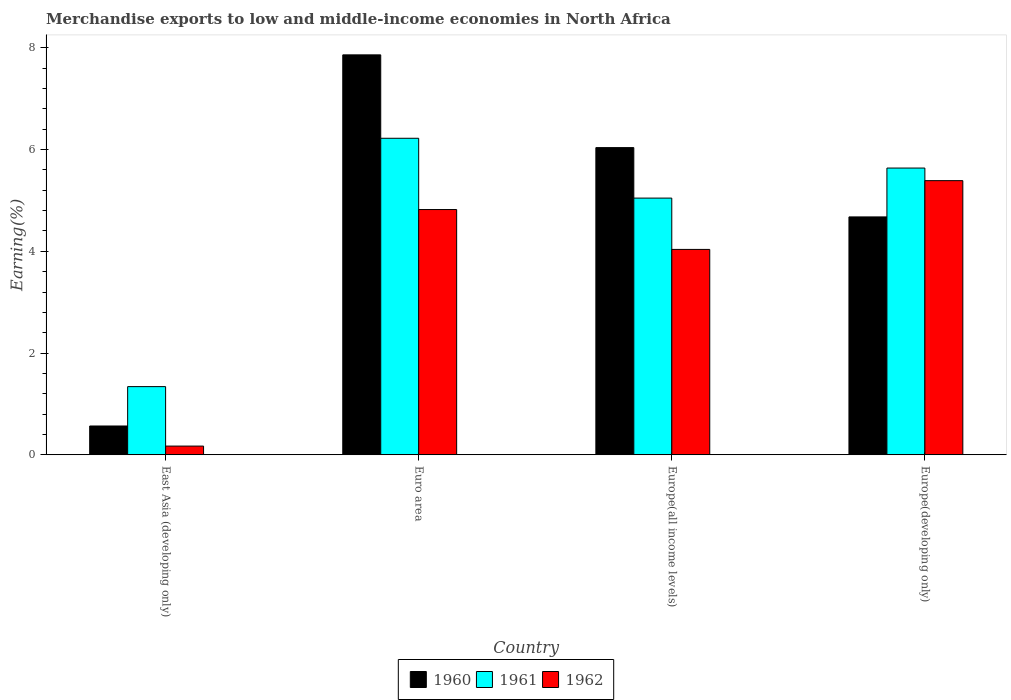How many different coloured bars are there?
Provide a succinct answer. 3. How many groups of bars are there?
Give a very brief answer. 4. How many bars are there on the 2nd tick from the right?
Give a very brief answer. 3. What is the label of the 2nd group of bars from the left?
Your answer should be very brief. Euro area. What is the percentage of amount earned from merchandise exports in 1962 in Europe(developing only)?
Your answer should be compact. 5.39. Across all countries, what is the maximum percentage of amount earned from merchandise exports in 1960?
Your answer should be compact. 7.86. Across all countries, what is the minimum percentage of amount earned from merchandise exports in 1960?
Your answer should be very brief. 0.57. In which country was the percentage of amount earned from merchandise exports in 1962 maximum?
Give a very brief answer. Europe(developing only). In which country was the percentage of amount earned from merchandise exports in 1961 minimum?
Offer a very short reply. East Asia (developing only). What is the total percentage of amount earned from merchandise exports in 1962 in the graph?
Your answer should be compact. 14.42. What is the difference between the percentage of amount earned from merchandise exports in 1961 in Euro area and that in Europe(developing only)?
Your answer should be very brief. 0.59. What is the difference between the percentage of amount earned from merchandise exports in 1960 in Euro area and the percentage of amount earned from merchandise exports in 1962 in Europe(all income levels)?
Provide a succinct answer. 3.82. What is the average percentage of amount earned from merchandise exports in 1961 per country?
Provide a short and direct response. 4.56. What is the difference between the percentage of amount earned from merchandise exports of/in 1962 and percentage of amount earned from merchandise exports of/in 1960 in Europe(developing only)?
Ensure brevity in your answer.  0.71. What is the ratio of the percentage of amount earned from merchandise exports in 1961 in Euro area to that in Europe(all income levels)?
Provide a succinct answer. 1.23. What is the difference between the highest and the second highest percentage of amount earned from merchandise exports in 1960?
Offer a very short reply. -1.36. What is the difference between the highest and the lowest percentage of amount earned from merchandise exports in 1962?
Your answer should be very brief. 5.22. Is the sum of the percentage of amount earned from merchandise exports in 1960 in Europe(all income levels) and Europe(developing only) greater than the maximum percentage of amount earned from merchandise exports in 1961 across all countries?
Make the answer very short. Yes. Are all the bars in the graph horizontal?
Provide a succinct answer. No. How many countries are there in the graph?
Your response must be concise. 4. What is the difference between two consecutive major ticks on the Y-axis?
Your answer should be very brief. 2. Are the values on the major ticks of Y-axis written in scientific E-notation?
Provide a short and direct response. No. How many legend labels are there?
Make the answer very short. 3. How are the legend labels stacked?
Ensure brevity in your answer.  Horizontal. What is the title of the graph?
Give a very brief answer. Merchandise exports to low and middle-income economies in North Africa. Does "1998" appear as one of the legend labels in the graph?
Keep it short and to the point. No. What is the label or title of the Y-axis?
Your response must be concise. Earning(%). What is the Earning(%) of 1960 in East Asia (developing only)?
Your response must be concise. 0.57. What is the Earning(%) of 1961 in East Asia (developing only)?
Ensure brevity in your answer.  1.34. What is the Earning(%) in 1962 in East Asia (developing only)?
Your answer should be very brief. 0.17. What is the Earning(%) of 1960 in Euro area?
Make the answer very short. 7.86. What is the Earning(%) in 1961 in Euro area?
Your answer should be very brief. 6.22. What is the Earning(%) of 1962 in Euro area?
Keep it short and to the point. 4.82. What is the Earning(%) in 1960 in Europe(all income levels)?
Provide a succinct answer. 6.04. What is the Earning(%) in 1961 in Europe(all income levels)?
Make the answer very short. 5.05. What is the Earning(%) in 1962 in Europe(all income levels)?
Ensure brevity in your answer.  4.04. What is the Earning(%) in 1960 in Europe(developing only)?
Ensure brevity in your answer.  4.68. What is the Earning(%) of 1961 in Europe(developing only)?
Offer a very short reply. 5.64. What is the Earning(%) of 1962 in Europe(developing only)?
Provide a short and direct response. 5.39. Across all countries, what is the maximum Earning(%) in 1960?
Your answer should be very brief. 7.86. Across all countries, what is the maximum Earning(%) in 1961?
Make the answer very short. 6.22. Across all countries, what is the maximum Earning(%) in 1962?
Offer a terse response. 5.39. Across all countries, what is the minimum Earning(%) in 1960?
Your answer should be very brief. 0.57. Across all countries, what is the minimum Earning(%) of 1961?
Provide a short and direct response. 1.34. Across all countries, what is the minimum Earning(%) in 1962?
Your answer should be very brief. 0.17. What is the total Earning(%) in 1960 in the graph?
Offer a terse response. 19.14. What is the total Earning(%) of 1961 in the graph?
Keep it short and to the point. 18.25. What is the total Earning(%) in 1962 in the graph?
Make the answer very short. 14.42. What is the difference between the Earning(%) of 1960 in East Asia (developing only) and that in Euro area?
Provide a succinct answer. -7.3. What is the difference between the Earning(%) in 1961 in East Asia (developing only) and that in Euro area?
Offer a very short reply. -4.88. What is the difference between the Earning(%) in 1962 in East Asia (developing only) and that in Euro area?
Your response must be concise. -4.65. What is the difference between the Earning(%) of 1960 in East Asia (developing only) and that in Europe(all income levels)?
Provide a succinct answer. -5.47. What is the difference between the Earning(%) of 1961 in East Asia (developing only) and that in Europe(all income levels)?
Provide a succinct answer. -3.71. What is the difference between the Earning(%) in 1962 in East Asia (developing only) and that in Europe(all income levels)?
Your answer should be very brief. -3.87. What is the difference between the Earning(%) in 1960 in East Asia (developing only) and that in Europe(developing only)?
Ensure brevity in your answer.  -4.11. What is the difference between the Earning(%) in 1961 in East Asia (developing only) and that in Europe(developing only)?
Your answer should be compact. -4.3. What is the difference between the Earning(%) in 1962 in East Asia (developing only) and that in Europe(developing only)?
Your response must be concise. -5.22. What is the difference between the Earning(%) of 1960 in Euro area and that in Europe(all income levels)?
Offer a very short reply. 1.82. What is the difference between the Earning(%) in 1961 in Euro area and that in Europe(all income levels)?
Your answer should be compact. 1.18. What is the difference between the Earning(%) of 1962 in Euro area and that in Europe(all income levels)?
Make the answer very short. 0.78. What is the difference between the Earning(%) of 1960 in Euro area and that in Europe(developing only)?
Offer a very short reply. 3.19. What is the difference between the Earning(%) in 1961 in Euro area and that in Europe(developing only)?
Provide a short and direct response. 0.59. What is the difference between the Earning(%) of 1962 in Euro area and that in Europe(developing only)?
Provide a succinct answer. -0.57. What is the difference between the Earning(%) of 1960 in Europe(all income levels) and that in Europe(developing only)?
Keep it short and to the point. 1.36. What is the difference between the Earning(%) in 1961 in Europe(all income levels) and that in Europe(developing only)?
Your answer should be compact. -0.59. What is the difference between the Earning(%) of 1962 in Europe(all income levels) and that in Europe(developing only)?
Provide a short and direct response. -1.35. What is the difference between the Earning(%) in 1960 in East Asia (developing only) and the Earning(%) in 1961 in Euro area?
Make the answer very short. -5.66. What is the difference between the Earning(%) of 1960 in East Asia (developing only) and the Earning(%) of 1962 in Euro area?
Provide a short and direct response. -4.26. What is the difference between the Earning(%) of 1961 in East Asia (developing only) and the Earning(%) of 1962 in Euro area?
Your answer should be very brief. -3.48. What is the difference between the Earning(%) in 1960 in East Asia (developing only) and the Earning(%) in 1961 in Europe(all income levels)?
Offer a very short reply. -4.48. What is the difference between the Earning(%) of 1960 in East Asia (developing only) and the Earning(%) of 1962 in Europe(all income levels)?
Offer a very short reply. -3.47. What is the difference between the Earning(%) of 1961 in East Asia (developing only) and the Earning(%) of 1962 in Europe(all income levels)?
Offer a terse response. -2.7. What is the difference between the Earning(%) of 1960 in East Asia (developing only) and the Earning(%) of 1961 in Europe(developing only)?
Your answer should be very brief. -5.07. What is the difference between the Earning(%) of 1960 in East Asia (developing only) and the Earning(%) of 1962 in Europe(developing only)?
Give a very brief answer. -4.82. What is the difference between the Earning(%) of 1961 in East Asia (developing only) and the Earning(%) of 1962 in Europe(developing only)?
Ensure brevity in your answer.  -4.05. What is the difference between the Earning(%) of 1960 in Euro area and the Earning(%) of 1961 in Europe(all income levels)?
Offer a terse response. 2.82. What is the difference between the Earning(%) of 1960 in Euro area and the Earning(%) of 1962 in Europe(all income levels)?
Make the answer very short. 3.82. What is the difference between the Earning(%) in 1961 in Euro area and the Earning(%) in 1962 in Europe(all income levels)?
Make the answer very short. 2.18. What is the difference between the Earning(%) of 1960 in Euro area and the Earning(%) of 1961 in Europe(developing only)?
Make the answer very short. 2.23. What is the difference between the Earning(%) in 1960 in Euro area and the Earning(%) in 1962 in Europe(developing only)?
Make the answer very short. 2.47. What is the difference between the Earning(%) of 1961 in Euro area and the Earning(%) of 1962 in Europe(developing only)?
Ensure brevity in your answer.  0.83. What is the difference between the Earning(%) in 1960 in Europe(all income levels) and the Earning(%) in 1961 in Europe(developing only)?
Give a very brief answer. 0.4. What is the difference between the Earning(%) in 1960 in Europe(all income levels) and the Earning(%) in 1962 in Europe(developing only)?
Keep it short and to the point. 0.65. What is the difference between the Earning(%) in 1961 in Europe(all income levels) and the Earning(%) in 1962 in Europe(developing only)?
Provide a succinct answer. -0.34. What is the average Earning(%) of 1960 per country?
Offer a terse response. 4.79. What is the average Earning(%) of 1961 per country?
Keep it short and to the point. 4.56. What is the average Earning(%) in 1962 per country?
Give a very brief answer. 3.61. What is the difference between the Earning(%) of 1960 and Earning(%) of 1961 in East Asia (developing only)?
Keep it short and to the point. -0.77. What is the difference between the Earning(%) in 1960 and Earning(%) in 1962 in East Asia (developing only)?
Give a very brief answer. 0.4. What is the difference between the Earning(%) in 1961 and Earning(%) in 1962 in East Asia (developing only)?
Give a very brief answer. 1.17. What is the difference between the Earning(%) in 1960 and Earning(%) in 1961 in Euro area?
Provide a succinct answer. 1.64. What is the difference between the Earning(%) in 1960 and Earning(%) in 1962 in Euro area?
Your answer should be very brief. 3.04. What is the difference between the Earning(%) of 1961 and Earning(%) of 1962 in Euro area?
Your answer should be compact. 1.4. What is the difference between the Earning(%) in 1960 and Earning(%) in 1961 in Europe(all income levels)?
Offer a very short reply. 0.99. What is the difference between the Earning(%) of 1960 and Earning(%) of 1962 in Europe(all income levels)?
Your answer should be very brief. 2. What is the difference between the Earning(%) in 1961 and Earning(%) in 1962 in Europe(all income levels)?
Your response must be concise. 1.01. What is the difference between the Earning(%) of 1960 and Earning(%) of 1961 in Europe(developing only)?
Ensure brevity in your answer.  -0.96. What is the difference between the Earning(%) in 1960 and Earning(%) in 1962 in Europe(developing only)?
Offer a terse response. -0.71. What is the difference between the Earning(%) in 1961 and Earning(%) in 1962 in Europe(developing only)?
Give a very brief answer. 0.25. What is the ratio of the Earning(%) of 1960 in East Asia (developing only) to that in Euro area?
Your answer should be very brief. 0.07. What is the ratio of the Earning(%) of 1961 in East Asia (developing only) to that in Euro area?
Offer a very short reply. 0.22. What is the ratio of the Earning(%) of 1962 in East Asia (developing only) to that in Euro area?
Keep it short and to the point. 0.04. What is the ratio of the Earning(%) of 1960 in East Asia (developing only) to that in Europe(all income levels)?
Ensure brevity in your answer.  0.09. What is the ratio of the Earning(%) of 1961 in East Asia (developing only) to that in Europe(all income levels)?
Make the answer very short. 0.27. What is the ratio of the Earning(%) of 1962 in East Asia (developing only) to that in Europe(all income levels)?
Your response must be concise. 0.04. What is the ratio of the Earning(%) of 1960 in East Asia (developing only) to that in Europe(developing only)?
Offer a terse response. 0.12. What is the ratio of the Earning(%) in 1961 in East Asia (developing only) to that in Europe(developing only)?
Offer a terse response. 0.24. What is the ratio of the Earning(%) of 1962 in East Asia (developing only) to that in Europe(developing only)?
Provide a short and direct response. 0.03. What is the ratio of the Earning(%) of 1960 in Euro area to that in Europe(all income levels)?
Provide a succinct answer. 1.3. What is the ratio of the Earning(%) of 1961 in Euro area to that in Europe(all income levels)?
Your response must be concise. 1.23. What is the ratio of the Earning(%) of 1962 in Euro area to that in Europe(all income levels)?
Your answer should be very brief. 1.19. What is the ratio of the Earning(%) in 1960 in Euro area to that in Europe(developing only)?
Provide a succinct answer. 1.68. What is the ratio of the Earning(%) of 1961 in Euro area to that in Europe(developing only)?
Give a very brief answer. 1.1. What is the ratio of the Earning(%) in 1962 in Euro area to that in Europe(developing only)?
Your answer should be very brief. 0.89. What is the ratio of the Earning(%) in 1960 in Europe(all income levels) to that in Europe(developing only)?
Your answer should be compact. 1.29. What is the ratio of the Earning(%) of 1961 in Europe(all income levels) to that in Europe(developing only)?
Your answer should be compact. 0.9. What is the ratio of the Earning(%) of 1962 in Europe(all income levels) to that in Europe(developing only)?
Your answer should be compact. 0.75. What is the difference between the highest and the second highest Earning(%) in 1960?
Give a very brief answer. 1.82. What is the difference between the highest and the second highest Earning(%) in 1961?
Offer a very short reply. 0.59. What is the difference between the highest and the second highest Earning(%) of 1962?
Your answer should be very brief. 0.57. What is the difference between the highest and the lowest Earning(%) in 1960?
Provide a short and direct response. 7.3. What is the difference between the highest and the lowest Earning(%) of 1961?
Provide a short and direct response. 4.88. What is the difference between the highest and the lowest Earning(%) in 1962?
Offer a very short reply. 5.22. 